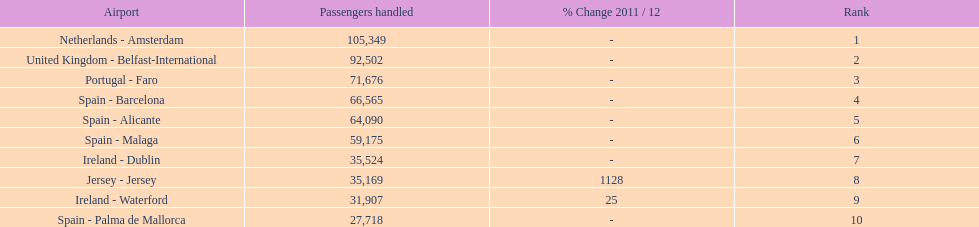How many airports are listed? 10. 